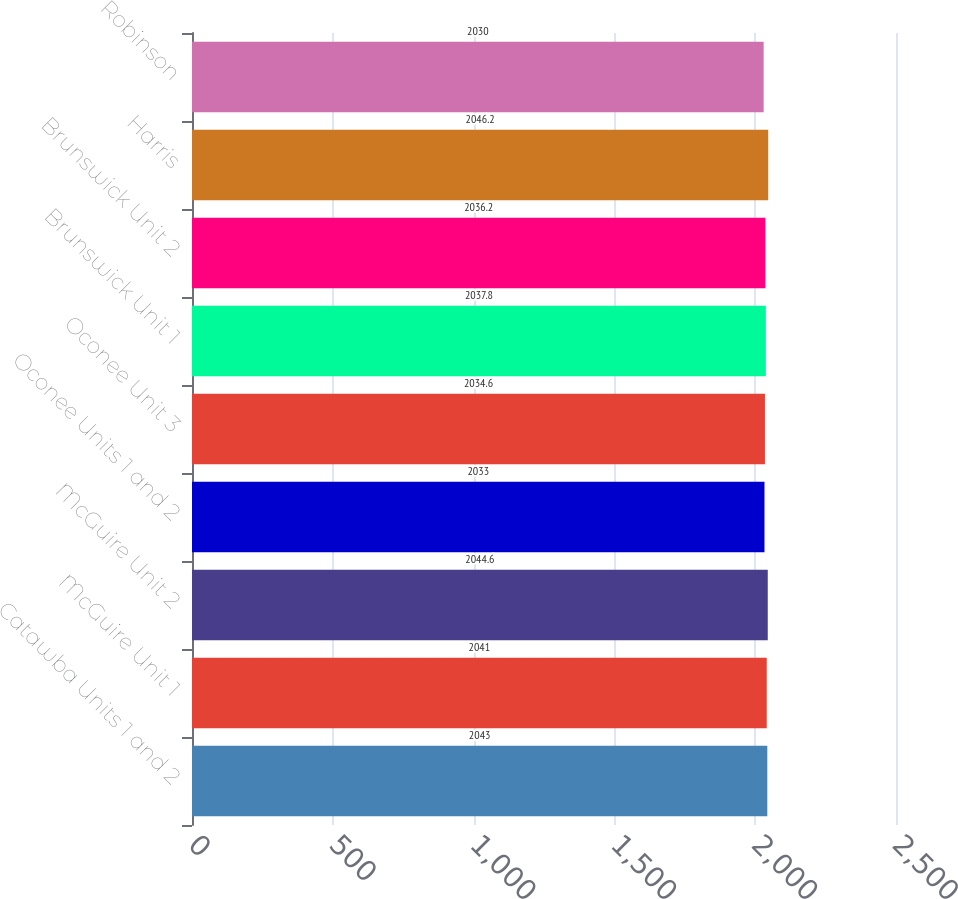Convert chart. <chart><loc_0><loc_0><loc_500><loc_500><bar_chart><fcel>Catawba Units 1 and 2<fcel>McGuire Unit 1<fcel>McGuire Unit 2<fcel>Oconee Units 1 and 2<fcel>Oconee Unit 3<fcel>Brunswick Unit 1<fcel>Brunswick Unit 2<fcel>Harris<fcel>Robinson<nl><fcel>2043<fcel>2041<fcel>2044.6<fcel>2033<fcel>2034.6<fcel>2037.8<fcel>2036.2<fcel>2046.2<fcel>2030<nl></chart> 